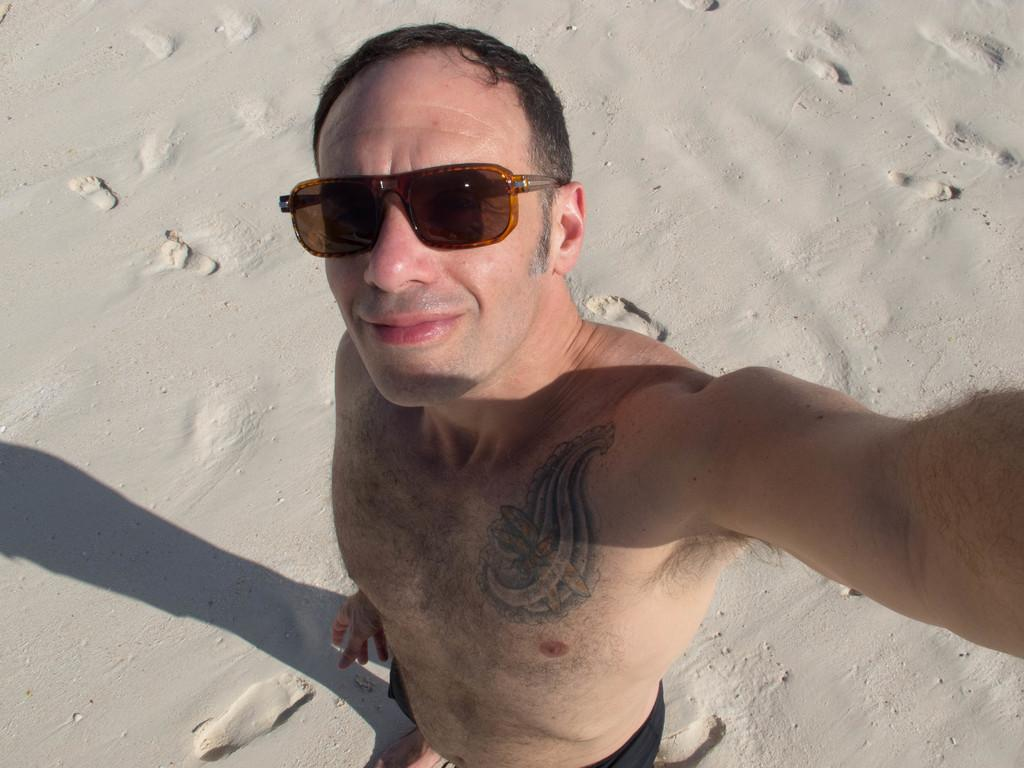What can be seen in the image related to a person? There is a person in the image. What type of clothing is the person wearing? The person is wearing black pants. What protective gear is the person wearing? The person is wearing goggles. What type of surface is the person standing on? The person is standing on sand. How would you describe the color of the sand? The sand is in an ash color. What type of grip does the person have on the steel object in the image? There is no steel object present in the image, and the person is not shown gripping any object. 